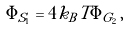Convert formula to latex. <formula><loc_0><loc_0><loc_500><loc_500>\Phi _ { S _ { 1 } } = 4 k _ { B } T \Phi _ { G _ { 2 } } \, ,</formula> 